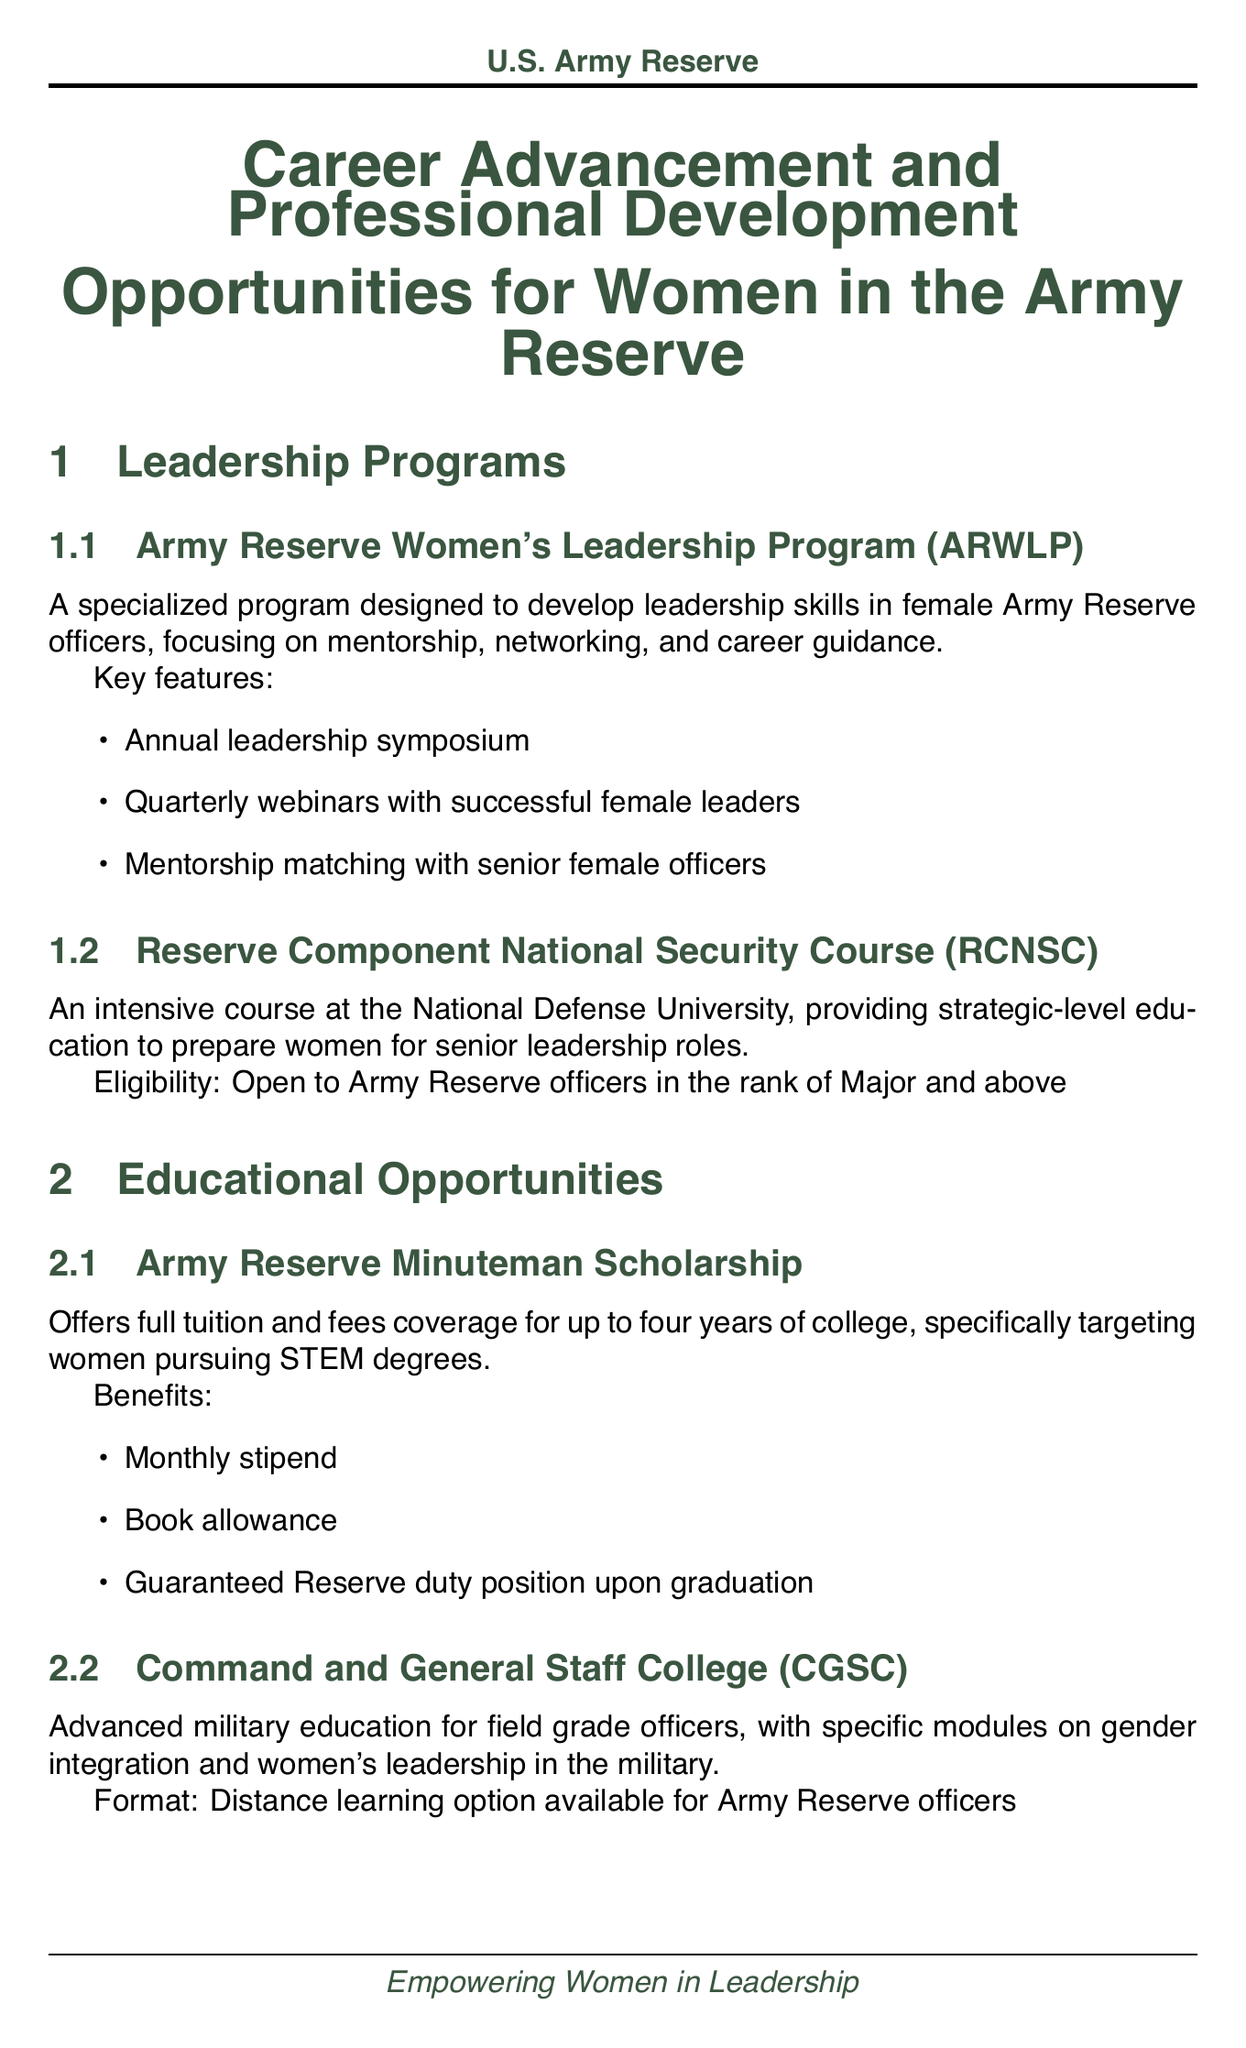What is the title of the document? The title of the document is stated at the beginning and is "Career Advancement and Professional Development Opportunities for Women in the Army Reserve."
Answer: Career Advancement and Professional Development Opportunities for Women in the Army Reserve What is the key feature of the Army Reserve Women's Leadership Program? One of the key features listed for the program is the "Annual leadership symposium."
Answer: Annual leadership symposium Who is eligible for the Reserve Component National Security Course? The document specifies that eligibility is "Open to Army Reserve officers in the rank of Major and above."
Answer: Open to Army Reserve officers in the rank of Major and above What scholarship targets women pursuing STEM degrees? The document mentions the "Army Reserve Minuteman Scholarship" specifically targeting women in STEM.
Answer: Army Reserve Minuteman Scholarship What activity is included in the Women's Mentorship Network? One of the activities mentioned is "Monthly one-on-one mentoring sessions."
Answer: Monthly one-on-one mentoring sessions What is the frequency of the Lean In Circles for Military Women? The document states that the meeting frequency is "Monthly, with both in-person and virtual options."
Answer: Monthly, with both in-person and virtual options What are the topics covered in the Women's Health and Fitness Symposium? The document lists several topics, one of them being "Nutrition for female athletes."
Answer: Nutrition for female athletes What type of event is the Army Reserve Women's Conference? The conference is described as an "Annual gathering of female Army Reserve members."
Answer: Annual gathering of female Army Reserve members What does the Women in Military Service for America Memorial Foundation offer? The document states it offers "networking events, educational resources, and recognition for women's contributions to the military."
Answer: networking events, educational resources, and recognition for women's contributions to the military 